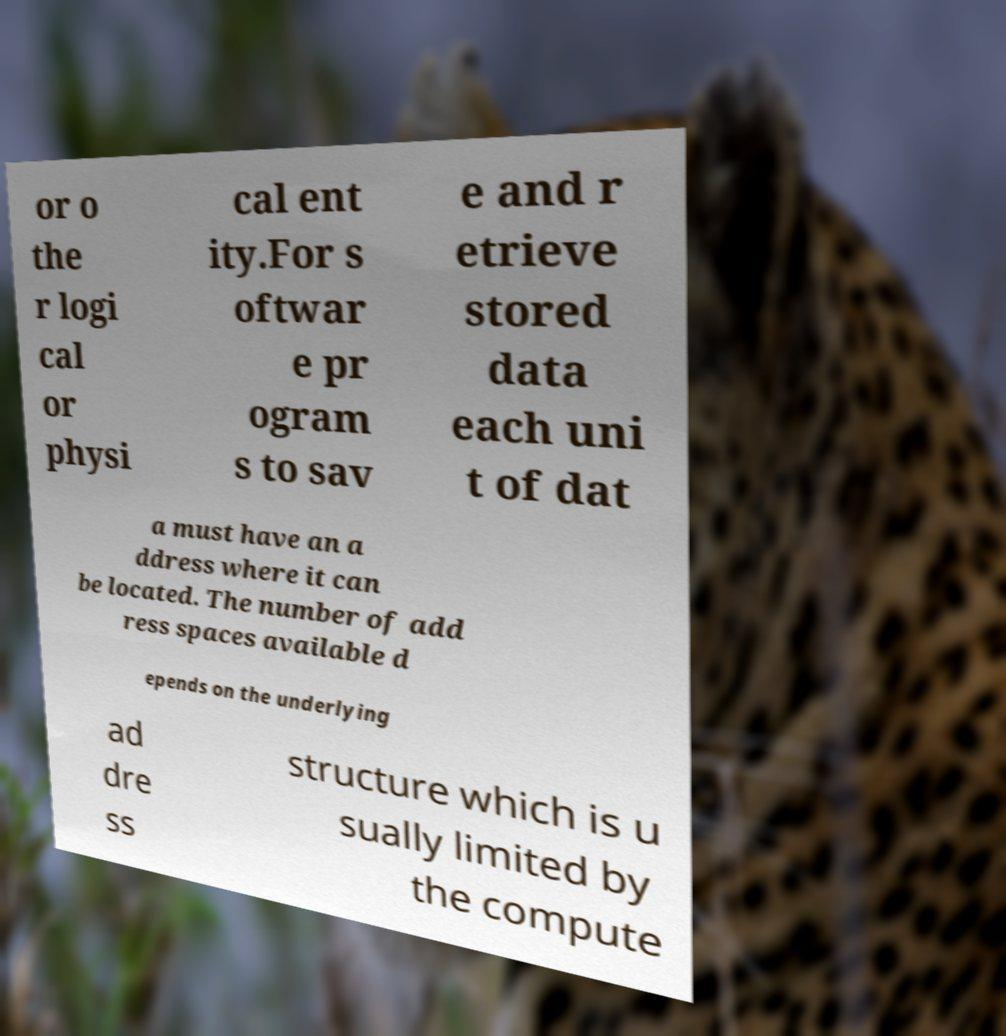What messages or text are displayed in this image? I need them in a readable, typed format. or o the r logi cal or physi cal ent ity.For s oftwar e pr ogram s to sav e and r etrieve stored data each uni t of dat a must have an a ddress where it can be located. The number of add ress spaces available d epends on the underlying ad dre ss structure which is u sually limited by the compute 